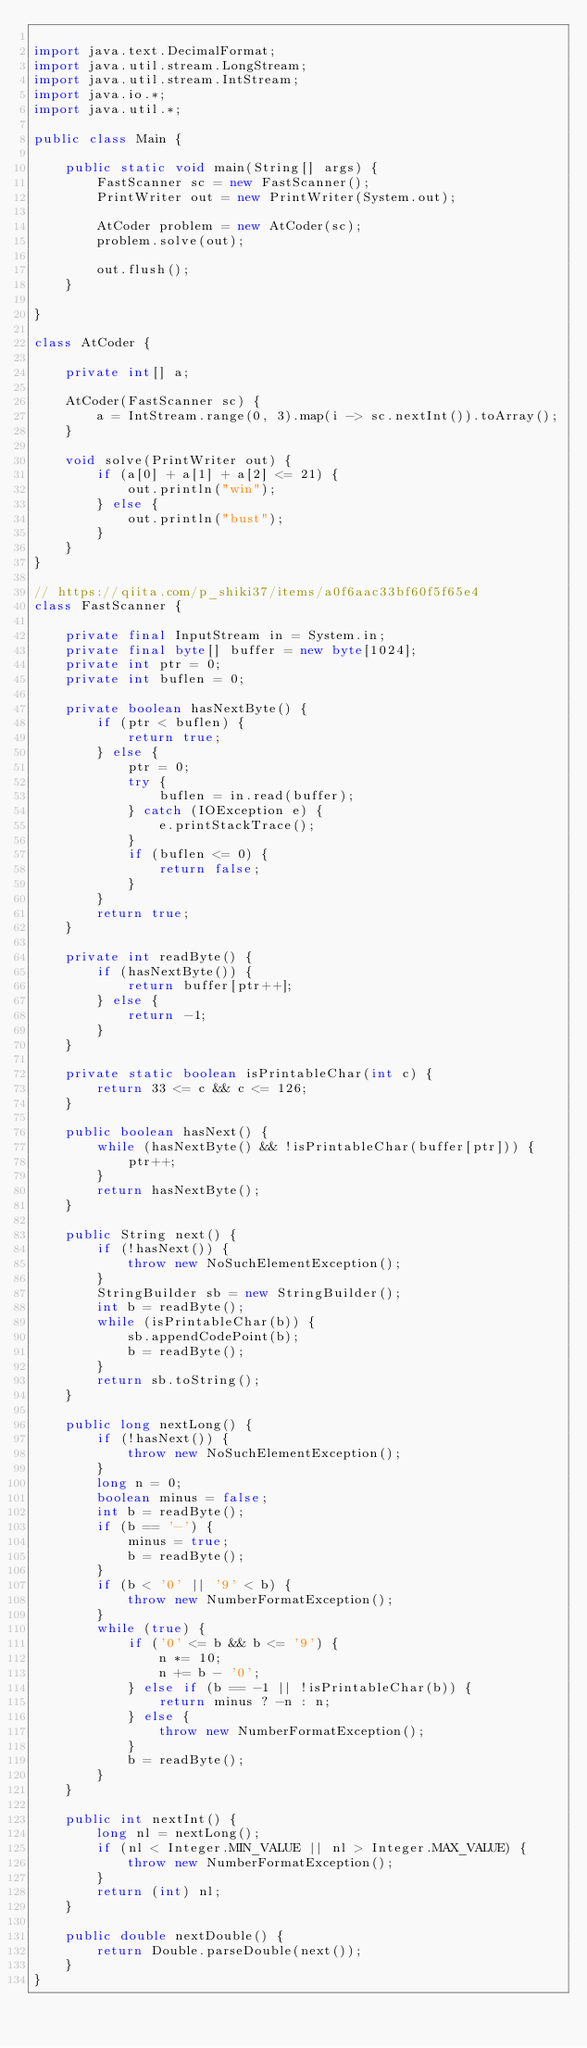Convert code to text. <code><loc_0><loc_0><loc_500><loc_500><_Java_>
import java.text.DecimalFormat;
import java.util.stream.LongStream;
import java.util.stream.IntStream;
import java.io.*;
import java.util.*;

public class Main {

    public static void main(String[] args) {
        FastScanner sc = new FastScanner();
        PrintWriter out = new PrintWriter(System.out);

        AtCoder problem = new AtCoder(sc);
        problem.solve(out);

        out.flush();
    }

}

class AtCoder {

    private int[] a;

    AtCoder(FastScanner sc) {
        a = IntStream.range(0, 3).map(i -> sc.nextInt()).toArray();
    }

    void solve(PrintWriter out) {
        if (a[0] + a[1] + a[2] <= 21) {
            out.println("win");
        } else {
            out.println("bust");
        }
    }
}

// https://qiita.com/p_shiki37/items/a0f6aac33bf60f5f65e4
class FastScanner {

    private final InputStream in = System.in;
    private final byte[] buffer = new byte[1024];
    private int ptr = 0;
    private int buflen = 0;

    private boolean hasNextByte() {
        if (ptr < buflen) {
            return true;
        } else {
            ptr = 0;
            try {
                buflen = in.read(buffer);
            } catch (IOException e) {
                e.printStackTrace();
            }
            if (buflen <= 0) {
                return false;
            }
        }
        return true;
    }

    private int readByte() {
        if (hasNextByte()) {
            return buffer[ptr++];
        } else {
            return -1;
        }
    }

    private static boolean isPrintableChar(int c) {
        return 33 <= c && c <= 126;
    }

    public boolean hasNext() {
        while (hasNextByte() && !isPrintableChar(buffer[ptr])) {
            ptr++;
        }
        return hasNextByte();
    }

    public String next() {
        if (!hasNext()) {
            throw new NoSuchElementException();
        }
        StringBuilder sb = new StringBuilder();
        int b = readByte();
        while (isPrintableChar(b)) {
            sb.appendCodePoint(b);
            b = readByte();
        }
        return sb.toString();
    }

    public long nextLong() {
        if (!hasNext()) {
            throw new NoSuchElementException();
        }
        long n = 0;
        boolean minus = false;
        int b = readByte();
        if (b == '-') {
            minus = true;
            b = readByte();
        }
        if (b < '0' || '9' < b) {
            throw new NumberFormatException();
        }
        while (true) {
            if ('0' <= b && b <= '9') {
                n *= 10;
                n += b - '0';
            } else if (b == -1 || !isPrintableChar(b)) {
                return minus ? -n : n;
            } else {
                throw new NumberFormatException();
            }
            b = readByte();
        }
    }

    public int nextInt() {
        long nl = nextLong();
        if (nl < Integer.MIN_VALUE || nl > Integer.MAX_VALUE) {
            throw new NumberFormatException();
        }
        return (int) nl;
    }

    public double nextDouble() {
        return Double.parseDouble(next());
    }
}
</code> 